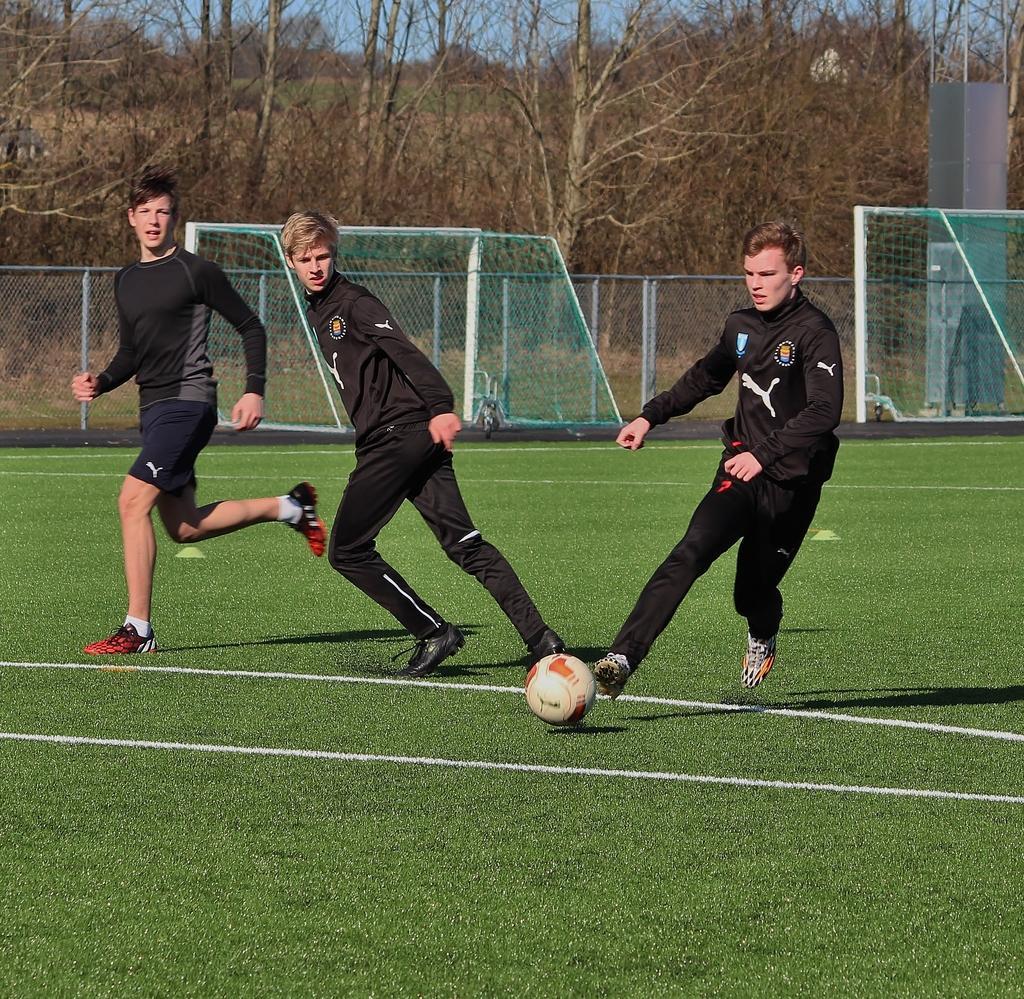Please provide a concise description of this image. Here we can see a group of persons running on the ground, and in front here is the ball, and at back here is the fencing, and here are the trees. 